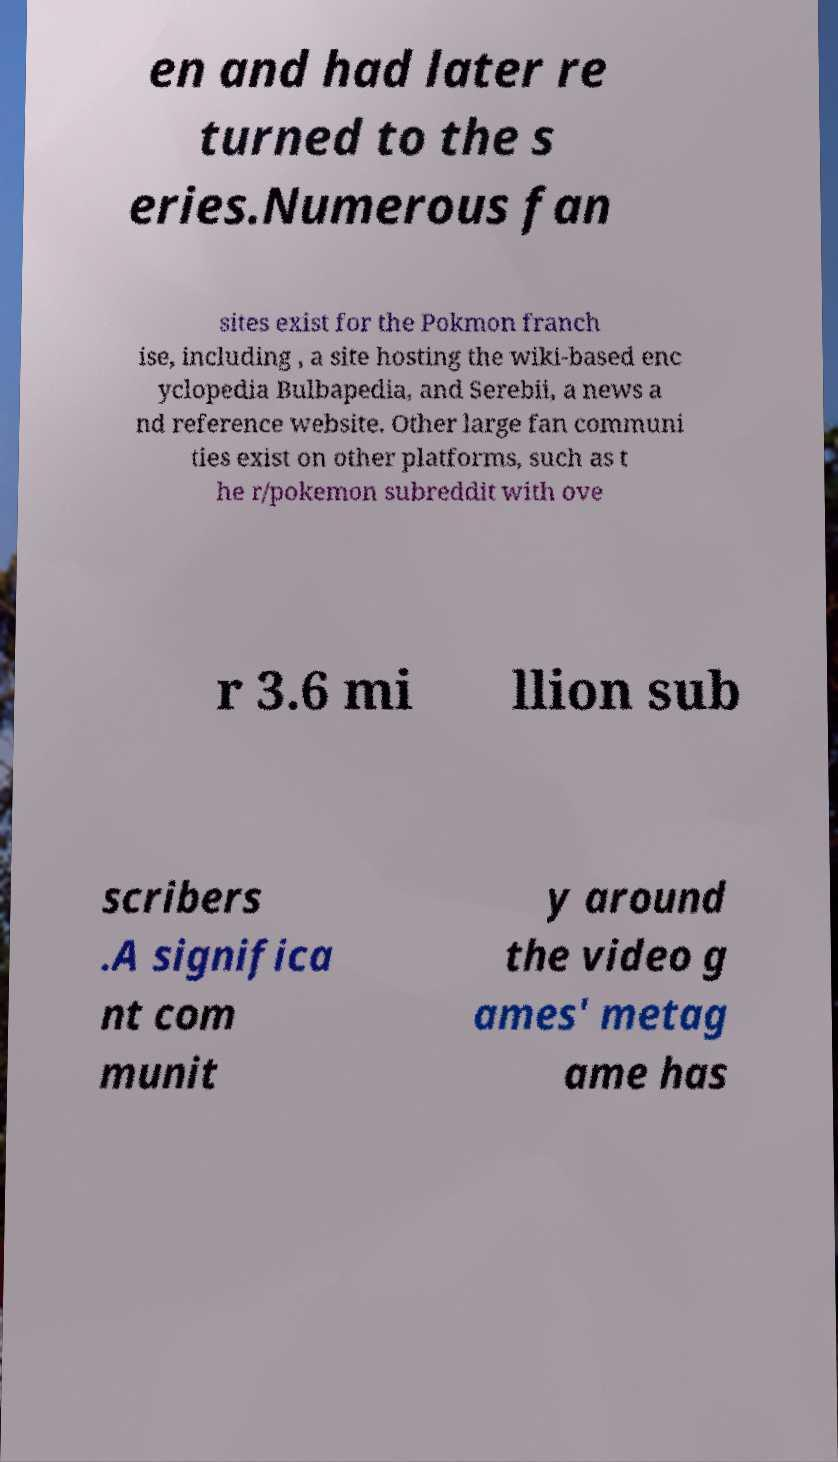Please read and relay the text visible in this image. What does it say? en and had later re turned to the s eries.Numerous fan sites exist for the Pokmon franch ise, including , a site hosting the wiki-based enc yclopedia Bulbapedia, and Serebii, a news a nd reference website. Other large fan communi ties exist on other platforms, such as t he r/pokemon subreddit with ove r 3.6 mi llion sub scribers .A significa nt com munit y around the video g ames' metag ame has 